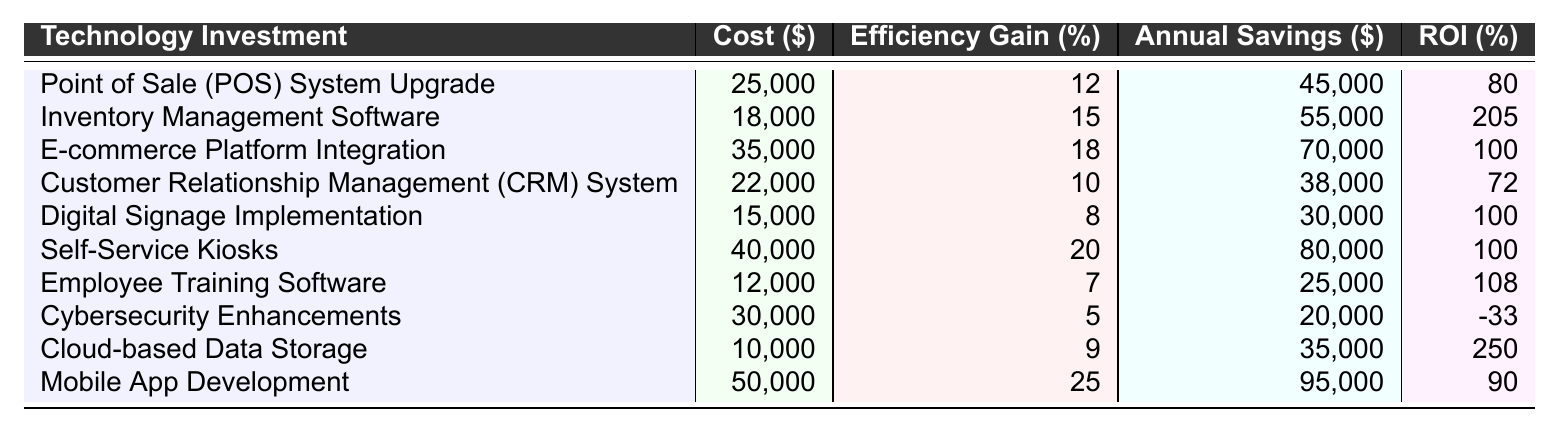What is the highest ROI percentage among the technology investments? By examining the ROI percentages for each technology investment in the table, the values are: 80, 205, 100, 72, 100, 100, 108, -33, 250, and 90. The highest value is 250 for Cloud-based Data Storage.
Answer: 250 Which technology investment had the lowest operational efficiency gain? Looking at the operational efficiency gain percentages, they are 12, 15, 18, 10, 8, 20, 7, 5, 9, and 25. The lowest value is 5 for Cybersecurity Enhancements.
Answer: Cybersecurity Enhancements How much was spent on technology investments with an ROI greater than 100%? The technology investments with an ROI greater than 100% are Inventory Management Software (18,000), Self-Service Kiosks (40,000), Employee Training Software (12,000), and Cloud-based Data Storage (10,000). Summing these gives: 18,000 + 40,000 + 12,000 + 10,000 = 80,000.
Answer: 80,000 What is the annual savings for the technology investment with the maximum operational efficiency gain? The technology investment with the maximum operational efficiency gain is Mobile App Development with an efficiency gain of 25%. Its annual savings is $95,000.
Answer: 95,000 Is there any technology investment that resulted in negative ROI? Checking the ROI column, we find that Cybersecurity Enhancements has a value of -33%, indicating a negative return on investment.
Answer: Yes What is the average annual savings across all technology investments? The annual savings values from the table are: 45,000, 55,000, 70,000, 38,000, 30,000, 80,000, 25,000, 20,000, 35,000, and 95,000. Summing these gives 45,000 + 55,000 + 70,000 + 38,000 + 30,000 + 80,000 + 25,000 + 20,000 + 35,000 + 95,000 =  495,000. Dividing this by the total number of investments (10), the average annual savings is 495,000 / 10 = 49,500.
Answer: 49,500 Which investment yielded an annual savings of $20,000? The annual savings of $20,000 corresponds to Cybersecurity Enhancements, as clearly stated in the table.
Answer: Cybersecurity Enhancements What is the total cost of technology investments with operational efficiency gains of 10% or less? The technology investments with 10% or less efficiency gains are CRM System (22,000), Digital Signage (15,000), Employee Training Software (12,000), and Cybersecurity Enhancements (30,000). Adding the costs: 22,000 + 15,000 + 12,000 + 30,000 = 79,000.
Answer: 79,000 How many technology investments had an operational efficiency gain greater than 15%? The operational efficiency gains greater than 15% are from Inventory Management Software (15%), E-commerce Platform Integration (18%), Self-Service Kiosks (20%), and Mobile App Development (25%). This gives a total of four investments.
Answer: 4 